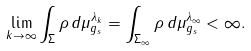Convert formula to latex. <formula><loc_0><loc_0><loc_500><loc_500>\lim _ { k \rightarrow \infty } \int _ { \Sigma } \rho \, d \mu _ { g _ { s } } ^ { \lambda _ { k } } = \int _ { \Sigma _ { \infty } } \rho \, d \mu _ { g _ { s } } ^ { \lambda _ { \infty } } < \infty .</formula> 